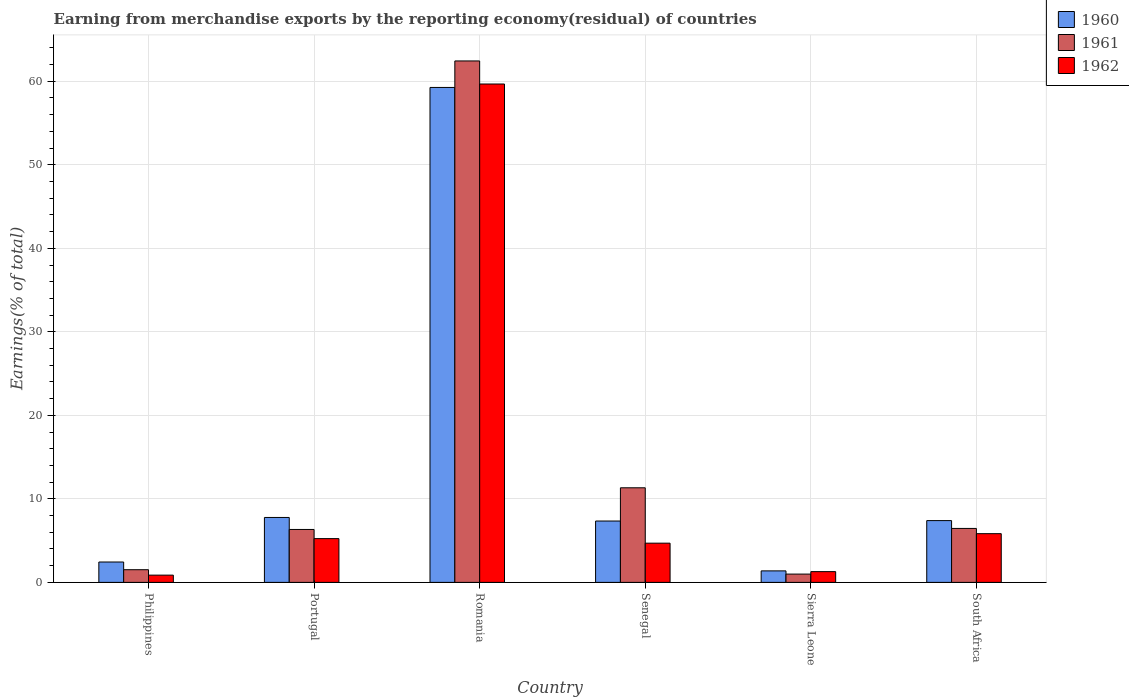How many different coloured bars are there?
Your answer should be very brief. 3. Are the number of bars per tick equal to the number of legend labels?
Make the answer very short. Yes. Are the number of bars on each tick of the X-axis equal?
Provide a short and direct response. Yes. How many bars are there on the 2nd tick from the left?
Your answer should be very brief. 3. How many bars are there on the 6th tick from the right?
Ensure brevity in your answer.  3. What is the label of the 4th group of bars from the left?
Keep it short and to the point. Senegal. In how many cases, is the number of bars for a given country not equal to the number of legend labels?
Provide a short and direct response. 0. What is the percentage of amount earned from merchandise exports in 1961 in Philippines?
Make the answer very short. 1.52. Across all countries, what is the maximum percentage of amount earned from merchandise exports in 1960?
Offer a very short reply. 59.26. Across all countries, what is the minimum percentage of amount earned from merchandise exports in 1962?
Your answer should be very brief. 0.87. In which country was the percentage of amount earned from merchandise exports in 1962 maximum?
Provide a succinct answer. Romania. What is the total percentage of amount earned from merchandise exports in 1960 in the graph?
Your answer should be very brief. 85.59. What is the difference between the percentage of amount earned from merchandise exports in 1962 in Portugal and that in Romania?
Give a very brief answer. -54.43. What is the difference between the percentage of amount earned from merchandise exports in 1962 in Philippines and the percentage of amount earned from merchandise exports in 1961 in Senegal?
Ensure brevity in your answer.  -10.46. What is the average percentage of amount earned from merchandise exports in 1960 per country?
Your answer should be compact. 14.27. What is the difference between the percentage of amount earned from merchandise exports of/in 1962 and percentage of amount earned from merchandise exports of/in 1960 in Romania?
Give a very brief answer. 0.41. What is the ratio of the percentage of amount earned from merchandise exports in 1961 in Romania to that in Senegal?
Make the answer very short. 5.51. Is the percentage of amount earned from merchandise exports in 1960 in Romania less than that in Senegal?
Your response must be concise. No. Is the difference between the percentage of amount earned from merchandise exports in 1962 in Sierra Leone and South Africa greater than the difference between the percentage of amount earned from merchandise exports in 1960 in Sierra Leone and South Africa?
Keep it short and to the point. Yes. What is the difference between the highest and the second highest percentage of amount earned from merchandise exports in 1961?
Your answer should be very brief. -51.11. What is the difference between the highest and the lowest percentage of amount earned from merchandise exports in 1960?
Your answer should be very brief. 57.88. What does the 2nd bar from the left in Senegal represents?
Offer a terse response. 1961. Is it the case that in every country, the sum of the percentage of amount earned from merchandise exports in 1960 and percentage of amount earned from merchandise exports in 1961 is greater than the percentage of amount earned from merchandise exports in 1962?
Your answer should be very brief. Yes. How many bars are there?
Ensure brevity in your answer.  18. Does the graph contain any zero values?
Keep it short and to the point. No. Where does the legend appear in the graph?
Provide a short and direct response. Top right. How many legend labels are there?
Provide a short and direct response. 3. What is the title of the graph?
Ensure brevity in your answer.  Earning from merchandise exports by the reporting economy(residual) of countries. What is the label or title of the Y-axis?
Keep it short and to the point. Earnings(% of total). What is the Earnings(% of total) in 1960 in Philippines?
Offer a very short reply. 2.44. What is the Earnings(% of total) of 1961 in Philippines?
Provide a short and direct response. 1.52. What is the Earnings(% of total) in 1962 in Philippines?
Your answer should be compact. 0.87. What is the Earnings(% of total) in 1960 in Portugal?
Your answer should be very brief. 7.77. What is the Earnings(% of total) in 1961 in Portugal?
Keep it short and to the point. 6.34. What is the Earnings(% of total) in 1962 in Portugal?
Make the answer very short. 5.24. What is the Earnings(% of total) of 1960 in Romania?
Provide a short and direct response. 59.26. What is the Earnings(% of total) in 1961 in Romania?
Ensure brevity in your answer.  62.43. What is the Earnings(% of total) of 1962 in Romania?
Make the answer very short. 59.67. What is the Earnings(% of total) in 1960 in Senegal?
Provide a short and direct response. 7.35. What is the Earnings(% of total) of 1961 in Senegal?
Give a very brief answer. 11.33. What is the Earnings(% of total) of 1962 in Senegal?
Your answer should be compact. 4.7. What is the Earnings(% of total) of 1960 in Sierra Leone?
Your response must be concise. 1.38. What is the Earnings(% of total) of 1961 in Sierra Leone?
Keep it short and to the point. 0.99. What is the Earnings(% of total) in 1962 in Sierra Leone?
Your answer should be very brief. 1.29. What is the Earnings(% of total) of 1960 in South Africa?
Ensure brevity in your answer.  7.4. What is the Earnings(% of total) in 1961 in South Africa?
Provide a succinct answer. 6.46. What is the Earnings(% of total) in 1962 in South Africa?
Your response must be concise. 5.83. Across all countries, what is the maximum Earnings(% of total) in 1960?
Your answer should be very brief. 59.26. Across all countries, what is the maximum Earnings(% of total) in 1961?
Ensure brevity in your answer.  62.43. Across all countries, what is the maximum Earnings(% of total) of 1962?
Offer a terse response. 59.67. Across all countries, what is the minimum Earnings(% of total) in 1960?
Keep it short and to the point. 1.38. Across all countries, what is the minimum Earnings(% of total) in 1961?
Offer a terse response. 0.99. Across all countries, what is the minimum Earnings(% of total) of 1962?
Provide a succinct answer. 0.87. What is the total Earnings(% of total) in 1960 in the graph?
Make the answer very short. 85.59. What is the total Earnings(% of total) of 1961 in the graph?
Provide a succinct answer. 89.07. What is the total Earnings(% of total) of 1962 in the graph?
Provide a succinct answer. 77.6. What is the difference between the Earnings(% of total) of 1960 in Philippines and that in Portugal?
Provide a succinct answer. -5.33. What is the difference between the Earnings(% of total) in 1961 in Philippines and that in Portugal?
Your response must be concise. -4.82. What is the difference between the Earnings(% of total) in 1962 in Philippines and that in Portugal?
Offer a terse response. -4.37. What is the difference between the Earnings(% of total) of 1960 in Philippines and that in Romania?
Offer a terse response. -56.82. What is the difference between the Earnings(% of total) of 1961 in Philippines and that in Romania?
Give a very brief answer. -60.91. What is the difference between the Earnings(% of total) in 1962 in Philippines and that in Romania?
Keep it short and to the point. -58.8. What is the difference between the Earnings(% of total) in 1960 in Philippines and that in Senegal?
Offer a terse response. -4.91. What is the difference between the Earnings(% of total) in 1961 in Philippines and that in Senegal?
Ensure brevity in your answer.  -9.81. What is the difference between the Earnings(% of total) in 1962 in Philippines and that in Senegal?
Offer a terse response. -3.83. What is the difference between the Earnings(% of total) in 1960 in Philippines and that in Sierra Leone?
Offer a terse response. 1.06. What is the difference between the Earnings(% of total) of 1961 in Philippines and that in Sierra Leone?
Your response must be concise. 0.53. What is the difference between the Earnings(% of total) of 1962 in Philippines and that in Sierra Leone?
Ensure brevity in your answer.  -0.42. What is the difference between the Earnings(% of total) in 1960 in Philippines and that in South Africa?
Offer a very short reply. -4.96. What is the difference between the Earnings(% of total) in 1961 in Philippines and that in South Africa?
Your answer should be very brief. -4.94. What is the difference between the Earnings(% of total) in 1962 in Philippines and that in South Africa?
Offer a terse response. -4.97. What is the difference between the Earnings(% of total) of 1960 in Portugal and that in Romania?
Provide a short and direct response. -51.49. What is the difference between the Earnings(% of total) of 1961 in Portugal and that in Romania?
Give a very brief answer. -56.1. What is the difference between the Earnings(% of total) of 1962 in Portugal and that in Romania?
Keep it short and to the point. -54.43. What is the difference between the Earnings(% of total) of 1960 in Portugal and that in Senegal?
Keep it short and to the point. 0.43. What is the difference between the Earnings(% of total) of 1961 in Portugal and that in Senegal?
Offer a terse response. -4.99. What is the difference between the Earnings(% of total) in 1962 in Portugal and that in Senegal?
Offer a very short reply. 0.54. What is the difference between the Earnings(% of total) of 1960 in Portugal and that in Sierra Leone?
Your response must be concise. 6.4. What is the difference between the Earnings(% of total) of 1961 in Portugal and that in Sierra Leone?
Make the answer very short. 5.34. What is the difference between the Earnings(% of total) in 1962 in Portugal and that in Sierra Leone?
Your response must be concise. 3.95. What is the difference between the Earnings(% of total) in 1960 in Portugal and that in South Africa?
Keep it short and to the point. 0.38. What is the difference between the Earnings(% of total) in 1961 in Portugal and that in South Africa?
Make the answer very short. -0.12. What is the difference between the Earnings(% of total) of 1962 in Portugal and that in South Africa?
Your answer should be very brief. -0.59. What is the difference between the Earnings(% of total) of 1960 in Romania and that in Senegal?
Your answer should be very brief. 51.91. What is the difference between the Earnings(% of total) in 1961 in Romania and that in Senegal?
Keep it short and to the point. 51.11. What is the difference between the Earnings(% of total) of 1962 in Romania and that in Senegal?
Keep it short and to the point. 54.97. What is the difference between the Earnings(% of total) in 1960 in Romania and that in Sierra Leone?
Provide a succinct answer. 57.88. What is the difference between the Earnings(% of total) in 1961 in Romania and that in Sierra Leone?
Provide a succinct answer. 61.44. What is the difference between the Earnings(% of total) in 1962 in Romania and that in Sierra Leone?
Keep it short and to the point. 58.38. What is the difference between the Earnings(% of total) in 1960 in Romania and that in South Africa?
Give a very brief answer. 51.86. What is the difference between the Earnings(% of total) of 1961 in Romania and that in South Africa?
Offer a very short reply. 55.97. What is the difference between the Earnings(% of total) of 1962 in Romania and that in South Africa?
Provide a short and direct response. 53.84. What is the difference between the Earnings(% of total) in 1960 in Senegal and that in Sierra Leone?
Provide a succinct answer. 5.97. What is the difference between the Earnings(% of total) of 1961 in Senegal and that in Sierra Leone?
Offer a terse response. 10.33. What is the difference between the Earnings(% of total) of 1962 in Senegal and that in Sierra Leone?
Provide a short and direct response. 3.41. What is the difference between the Earnings(% of total) of 1960 in Senegal and that in South Africa?
Your response must be concise. -0.05. What is the difference between the Earnings(% of total) in 1961 in Senegal and that in South Africa?
Offer a very short reply. 4.87. What is the difference between the Earnings(% of total) of 1962 in Senegal and that in South Africa?
Keep it short and to the point. -1.14. What is the difference between the Earnings(% of total) in 1960 in Sierra Leone and that in South Africa?
Provide a succinct answer. -6.02. What is the difference between the Earnings(% of total) in 1961 in Sierra Leone and that in South Africa?
Give a very brief answer. -5.47. What is the difference between the Earnings(% of total) of 1962 in Sierra Leone and that in South Africa?
Make the answer very short. -4.55. What is the difference between the Earnings(% of total) in 1960 in Philippines and the Earnings(% of total) in 1961 in Portugal?
Make the answer very short. -3.9. What is the difference between the Earnings(% of total) in 1960 in Philippines and the Earnings(% of total) in 1962 in Portugal?
Offer a very short reply. -2.8. What is the difference between the Earnings(% of total) of 1961 in Philippines and the Earnings(% of total) of 1962 in Portugal?
Your answer should be very brief. -3.72. What is the difference between the Earnings(% of total) of 1960 in Philippines and the Earnings(% of total) of 1961 in Romania?
Offer a very short reply. -59.99. What is the difference between the Earnings(% of total) in 1960 in Philippines and the Earnings(% of total) in 1962 in Romania?
Your response must be concise. -57.23. What is the difference between the Earnings(% of total) of 1961 in Philippines and the Earnings(% of total) of 1962 in Romania?
Make the answer very short. -58.15. What is the difference between the Earnings(% of total) of 1960 in Philippines and the Earnings(% of total) of 1961 in Senegal?
Provide a short and direct response. -8.89. What is the difference between the Earnings(% of total) in 1960 in Philippines and the Earnings(% of total) in 1962 in Senegal?
Provide a short and direct response. -2.26. What is the difference between the Earnings(% of total) of 1961 in Philippines and the Earnings(% of total) of 1962 in Senegal?
Offer a terse response. -3.18. What is the difference between the Earnings(% of total) in 1960 in Philippines and the Earnings(% of total) in 1961 in Sierra Leone?
Offer a terse response. 1.45. What is the difference between the Earnings(% of total) of 1960 in Philippines and the Earnings(% of total) of 1962 in Sierra Leone?
Keep it short and to the point. 1.15. What is the difference between the Earnings(% of total) in 1961 in Philippines and the Earnings(% of total) in 1962 in Sierra Leone?
Make the answer very short. 0.23. What is the difference between the Earnings(% of total) of 1960 in Philippines and the Earnings(% of total) of 1961 in South Africa?
Provide a succinct answer. -4.02. What is the difference between the Earnings(% of total) in 1960 in Philippines and the Earnings(% of total) in 1962 in South Africa?
Give a very brief answer. -3.39. What is the difference between the Earnings(% of total) in 1961 in Philippines and the Earnings(% of total) in 1962 in South Africa?
Provide a succinct answer. -4.32. What is the difference between the Earnings(% of total) in 1960 in Portugal and the Earnings(% of total) in 1961 in Romania?
Your response must be concise. -54.66. What is the difference between the Earnings(% of total) of 1960 in Portugal and the Earnings(% of total) of 1962 in Romania?
Make the answer very short. -51.9. What is the difference between the Earnings(% of total) in 1961 in Portugal and the Earnings(% of total) in 1962 in Romania?
Offer a very short reply. -53.33. What is the difference between the Earnings(% of total) of 1960 in Portugal and the Earnings(% of total) of 1961 in Senegal?
Provide a succinct answer. -3.55. What is the difference between the Earnings(% of total) of 1960 in Portugal and the Earnings(% of total) of 1962 in Senegal?
Provide a short and direct response. 3.08. What is the difference between the Earnings(% of total) in 1961 in Portugal and the Earnings(% of total) in 1962 in Senegal?
Keep it short and to the point. 1.64. What is the difference between the Earnings(% of total) of 1960 in Portugal and the Earnings(% of total) of 1961 in Sierra Leone?
Your answer should be very brief. 6.78. What is the difference between the Earnings(% of total) in 1960 in Portugal and the Earnings(% of total) in 1962 in Sierra Leone?
Offer a terse response. 6.49. What is the difference between the Earnings(% of total) of 1961 in Portugal and the Earnings(% of total) of 1962 in Sierra Leone?
Your answer should be very brief. 5.05. What is the difference between the Earnings(% of total) in 1960 in Portugal and the Earnings(% of total) in 1961 in South Africa?
Your answer should be very brief. 1.31. What is the difference between the Earnings(% of total) of 1960 in Portugal and the Earnings(% of total) of 1962 in South Africa?
Your answer should be very brief. 1.94. What is the difference between the Earnings(% of total) of 1961 in Portugal and the Earnings(% of total) of 1962 in South Africa?
Your response must be concise. 0.5. What is the difference between the Earnings(% of total) in 1960 in Romania and the Earnings(% of total) in 1961 in Senegal?
Offer a very short reply. 47.93. What is the difference between the Earnings(% of total) in 1960 in Romania and the Earnings(% of total) in 1962 in Senegal?
Offer a very short reply. 54.56. What is the difference between the Earnings(% of total) in 1961 in Romania and the Earnings(% of total) in 1962 in Senegal?
Provide a succinct answer. 57.74. What is the difference between the Earnings(% of total) of 1960 in Romania and the Earnings(% of total) of 1961 in Sierra Leone?
Keep it short and to the point. 58.27. What is the difference between the Earnings(% of total) of 1960 in Romania and the Earnings(% of total) of 1962 in Sierra Leone?
Keep it short and to the point. 57.97. What is the difference between the Earnings(% of total) in 1961 in Romania and the Earnings(% of total) in 1962 in Sierra Leone?
Give a very brief answer. 61.15. What is the difference between the Earnings(% of total) of 1960 in Romania and the Earnings(% of total) of 1961 in South Africa?
Your answer should be very brief. 52.8. What is the difference between the Earnings(% of total) in 1960 in Romania and the Earnings(% of total) in 1962 in South Africa?
Give a very brief answer. 53.43. What is the difference between the Earnings(% of total) of 1961 in Romania and the Earnings(% of total) of 1962 in South Africa?
Ensure brevity in your answer.  56.6. What is the difference between the Earnings(% of total) in 1960 in Senegal and the Earnings(% of total) in 1961 in Sierra Leone?
Give a very brief answer. 6.35. What is the difference between the Earnings(% of total) in 1960 in Senegal and the Earnings(% of total) in 1962 in Sierra Leone?
Provide a succinct answer. 6.06. What is the difference between the Earnings(% of total) in 1961 in Senegal and the Earnings(% of total) in 1962 in Sierra Leone?
Offer a very short reply. 10.04. What is the difference between the Earnings(% of total) in 1960 in Senegal and the Earnings(% of total) in 1961 in South Africa?
Provide a succinct answer. 0.89. What is the difference between the Earnings(% of total) of 1960 in Senegal and the Earnings(% of total) of 1962 in South Africa?
Provide a short and direct response. 1.51. What is the difference between the Earnings(% of total) in 1961 in Senegal and the Earnings(% of total) in 1962 in South Africa?
Your answer should be very brief. 5.49. What is the difference between the Earnings(% of total) in 1960 in Sierra Leone and the Earnings(% of total) in 1961 in South Africa?
Offer a very short reply. -5.08. What is the difference between the Earnings(% of total) in 1960 in Sierra Leone and the Earnings(% of total) in 1962 in South Africa?
Your answer should be compact. -4.46. What is the difference between the Earnings(% of total) in 1961 in Sierra Leone and the Earnings(% of total) in 1962 in South Africa?
Make the answer very short. -4.84. What is the average Earnings(% of total) of 1960 per country?
Offer a very short reply. 14.27. What is the average Earnings(% of total) of 1961 per country?
Give a very brief answer. 14.84. What is the average Earnings(% of total) of 1962 per country?
Make the answer very short. 12.93. What is the difference between the Earnings(% of total) in 1960 and Earnings(% of total) in 1961 in Philippines?
Make the answer very short. 0.92. What is the difference between the Earnings(% of total) of 1960 and Earnings(% of total) of 1962 in Philippines?
Give a very brief answer. 1.57. What is the difference between the Earnings(% of total) of 1961 and Earnings(% of total) of 1962 in Philippines?
Your answer should be very brief. 0.65. What is the difference between the Earnings(% of total) in 1960 and Earnings(% of total) in 1961 in Portugal?
Provide a succinct answer. 1.44. What is the difference between the Earnings(% of total) in 1960 and Earnings(% of total) in 1962 in Portugal?
Provide a short and direct response. 2.53. What is the difference between the Earnings(% of total) of 1961 and Earnings(% of total) of 1962 in Portugal?
Your answer should be compact. 1.1. What is the difference between the Earnings(% of total) of 1960 and Earnings(% of total) of 1961 in Romania?
Ensure brevity in your answer.  -3.17. What is the difference between the Earnings(% of total) in 1960 and Earnings(% of total) in 1962 in Romania?
Give a very brief answer. -0.41. What is the difference between the Earnings(% of total) in 1961 and Earnings(% of total) in 1962 in Romania?
Keep it short and to the point. 2.76. What is the difference between the Earnings(% of total) of 1960 and Earnings(% of total) of 1961 in Senegal?
Offer a very short reply. -3.98. What is the difference between the Earnings(% of total) in 1960 and Earnings(% of total) in 1962 in Senegal?
Make the answer very short. 2.65. What is the difference between the Earnings(% of total) in 1961 and Earnings(% of total) in 1962 in Senegal?
Offer a very short reply. 6.63. What is the difference between the Earnings(% of total) of 1960 and Earnings(% of total) of 1961 in Sierra Leone?
Your answer should be very brief. 0.38. What is the difference between the Earnings(% of total) in 1960 and Earnings(% of total) in 1962 in Sierra Leone?
Give a very brief answer. 0.09. What is the difference between the Earnings(% of total) of 1961 and Earnings(% of total) of 1962 in Sierra Leone?
Make the answer very short. -0.29. What is the difference between the Earnings(% of total) of 1960 and Earnings(% of total) of 1961 in South Africa?
Offer a very short reply. 0.94. What is the difference between the Earnings(% of total) of 1960 and Earnings(% of total) of 1962 in South Africa?
Make the answer very short. 1.56. What is the difference between the Earnings(% of total) of 1961 and Earnings(% of total) of 1962 in South Africa?
Make the answer very short. 0.63. What is the ratio of the Earnings(% of total) of 1960 in Philippines to that in Portugal?
Provide a short and direct response. 0.31. What is the ratio of the Earnings(% of total) of 1961 in Philippines to that in Portugal?
Give a very brief answer. 0.24. What is the ratio of the Earnings(% of total) in 1962 in Philippines to that in Portugal?
Ensure brevity in your answer.  0.17. What is the ratio of the Earnings(% of total) in 1960 in Philippines to that in Romania?
Your answer should be very brief. 0.04. What is the ratio of the Earnings(% of total) of 1961 in Philippines to that in Romania?
Your answer should be very brief. 0.02. What is the ratio of the Earnings(% of total) of 1962 in Philippines to that in Romania?
Keep it short and to the point. 0.01. What is the ratio of the Earnings(% of total) of 1960 in Philippines to that in Senegal?
Your answer should be compact. 0.33. What is the ratio of the Earnings(% of total) in 1961 in Philippines to that in Senegal?
Provide a short and direct response. 0.13. What is the ratio of the Earnings(% of total) of 1962 in Philippines to that in Senegal?
Your response must be concise. 0.18. What is the ratio of the Earnings(% of total) in 1960 in Philippines to that in Sierra Leone?
Make the answer very short. 1.77. What is the ratio of the Earnings(% of total) in 1961 in Philippines to that in Sierra Leone?
Provide a short and direct response. 1.53. What is the ratio of the Earnings(% of total) of 1962 in Philippines to that in Sierra Leone?
Keep it short and to the point. 0.67. What is the ratio of the Earnings(% of total) in 1960 in Philippines to that in South Africa?
Your response must be concise. 0.33. What is the ratio of the Earnings(% of total) of 1961 in Philippines to that in South Africa?
Keep it short and to the point. 0.23. What is the ratio of the Earnings(% of total) in 1962 in Philippines to that in South Africa?
Offer a terse response. 0.15. What is the ratio of the Earnings(% of total) of 1960 in Portugal to that in Romania?
Make the answer very short. 0.13. What is the ratio of the Earnings(% of total) of 1961 in Portugal to that in Romania?
Give a very brief answer. 0.1. What is the ratio of the Earnings(% of total) of 1962 in Portugal to that in Romania?
Provide a short and direct response. 0.09. What is the ratio of the Earnings(% of total) of 1960 in Portugal to that in Senegal?
Ensure brevity in your answer.  1.06. What is the ratio of the Earnings(% of total) in 1961 in Portugal to that in Senegal?
Give a very brief answer. 0.56. What is the ratio of the Earnings(% of total) of 1962 in Portugal to that in Senegal?
Your answer should be very brief. 1.12. What is the ratio of the Earnings(% of total) of 1960 in Portugal to that in Sierra Leone?
Keep it short and to the point. 5.64. What is the ratio of the Earnings(% of total) in 1961 in Portugal to that in Sierra Leone?
Provide a short and direct response. 6.38. What is the ratio of the Earnings(% of total) of 1962 in Portugal to that in Sierra Leone?
Give a very brief answer. 4.07. What is the ratio of the Earnings(% of total) of 1960 in Portugal to that in South Africa?
Offer a terse response. 1.05. What is the ratio of the Earnings(% of total) in 1961 in Portugal to that in South Africa?
Your response must be concise. 0.98. What is the ratio of the Earnings(% of total) of 1962 in Portugal to that in South Africa?
Your response must be concise. 0.9. What is the ratio of the Earnings(% of total) in 1960 in Romania to that in Senegal?
Your answer should be compact. 8.06. What is the ratio of the Earnings(% of total) of 1961 in Romania to that in Senegal?
Your response must be concise. 5.51. What is the ratio of the Earnings(% of total) of 1962 in Romania to that in Senegal?
Give a very brief answer. 12.71. What is the ratio of the Earnings(% of total) in 1960 in Romania to that in Sierra Leone?
Offer a very short reply. 43.02. What is the ratio of the Earnings(% of total) in 1961 in Romania to that in Sierra Leone?
Give a very brief answer. 62.88. What is the ratio of the Earnings(% of total) of 1962 in Romania to that in Sierra Leone?
Your answer should be compact. 46.34. What is the ratio of the Earnings(% of total) of 1960 in Romania to that in South Africa?
Provide a succinct answer. 8.01. What is the ratio of the Earnings(% of total) in 1961 in Romania to that in South Africa?
Ensure brevity in your answer.  9.67. What is the ratio of the Earnings(% of total) of 1962 in Romania to that in South Africa?
Your answer should be compact. 10.23. What is the ratio of the Earnings(% of total) in 1960 in Senegal to that in Sierra Leone?
Provide a short and direct response. 5.33. What is the ratio of the Earnings(% of total) in 1961 in Senegal to that in Sierra Leone?
Offer a very short reply. 11.41. What is the ratio of the Earnings(% of total) of 1962 in Senegal to that in Sierra Leone?
Keep it short and to the point. 3.65. What is the ratio of the Earnings(% of total) of 1960 in Senegal to that in South Africa?
Give a very brief answer. 0.99. What is the ratio of the Earnings(% of total) in 1961 in Senegal to that in South Africa?
Make the answer very short. 1.75. What is the ratio of the Earnings(% of total) in 1962 in Senegal to that in South Africa?
Provide a succinct answer. 0.81. What is the ratio of the Earnings(% of total) of 1960 in Sierra Leone to that in South Africa?
Your response must be concise. 0.19. What is the ratio of the Earnings(% of total) in 1961 in Sierra Leone to that in South Africa?
Your answer should be very brief. 0.15. What is the ratio of the Earnings(% of total) of 1962 in Sierra Leone to that in South Africa?
Ensure brevity in your answer.  0.22. What is the difference between the highest and the second highest Earnings(% of total) in 1960?
Provide a succinct answer. 51.49. What is the difference between the highest and the second highest Earnings(% of total) in 1961?
Your answer should be compact. 51.11. What is the difference between the highest and the second highest Earnings(% of total) of 1962?
Make the answer very short. 53.84. What is the difference between the highest and the lowest Earnings(% of total) in 1960?
Your answer should be compact. 57.88. What is the difference between the highest and the lowest Earnings(% of total) in 1961?
Your response must be concise. 61.44. What is the difference between the highest and the lowest Earnings(% of total) in 1962?
Your answer should be very brief. 58.8. 